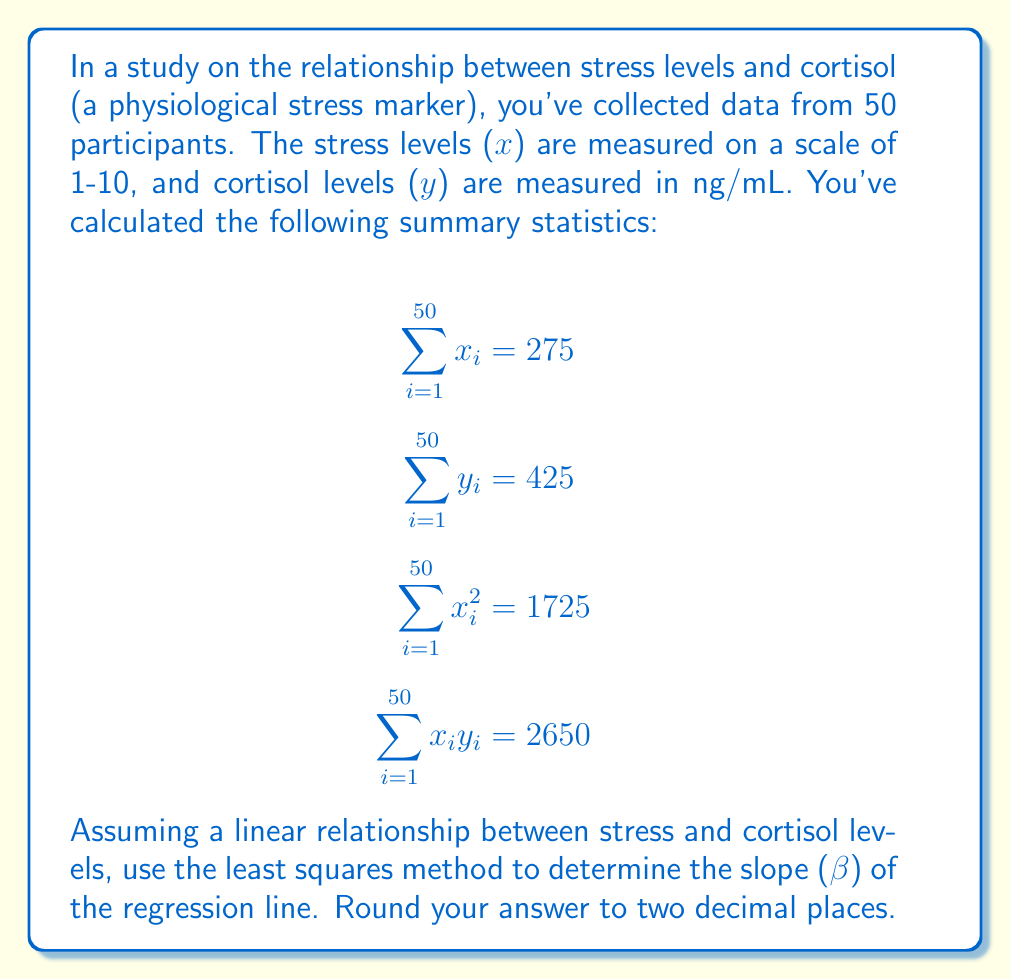Show me your answer to this math problem. To find the slope (β) of the regression line using the least squares method, we'll follow these steps:

1) The formula for the slope in simple linear regression is:

   $$\beta = \frac{n\sum x_iy_i - \sum x_i \sum y_i}{n\sum x_i^2 - (\sum x_i)^2}$$

   Where n is the number of data points.

2) We're given:
   n = 50
   $\sum x_i = 275$
   $\sum y_i = 425$
   $\sum x_i^2 = 1725$
   $\sum x_iy_i = 2650$

3) Let's substitute these values into the formula:

   $$\beta = \frac{50(2650) - (275)(425)}{50(1725) - (275)^2}$$

4) Simplify the numerator:
   $50(2650) = 132500$
   $(275)(425) = 116875$
   $132500 - 116875 = 15625$

5) Simplify the denominator:
   $50(1725) = 86250$
   $(275)^2 = 75625$
   $86250 - 75625 = 10625$

6) Now our equation looks like:

   $$\beta = \frac{15625}{10625}$$

7) Divide:
   $\beta ≈ 1.4705882352941178$

8) Rounding to two decimal places:
   $\beta ≈ 1.47$
Answer: $1.47$ 